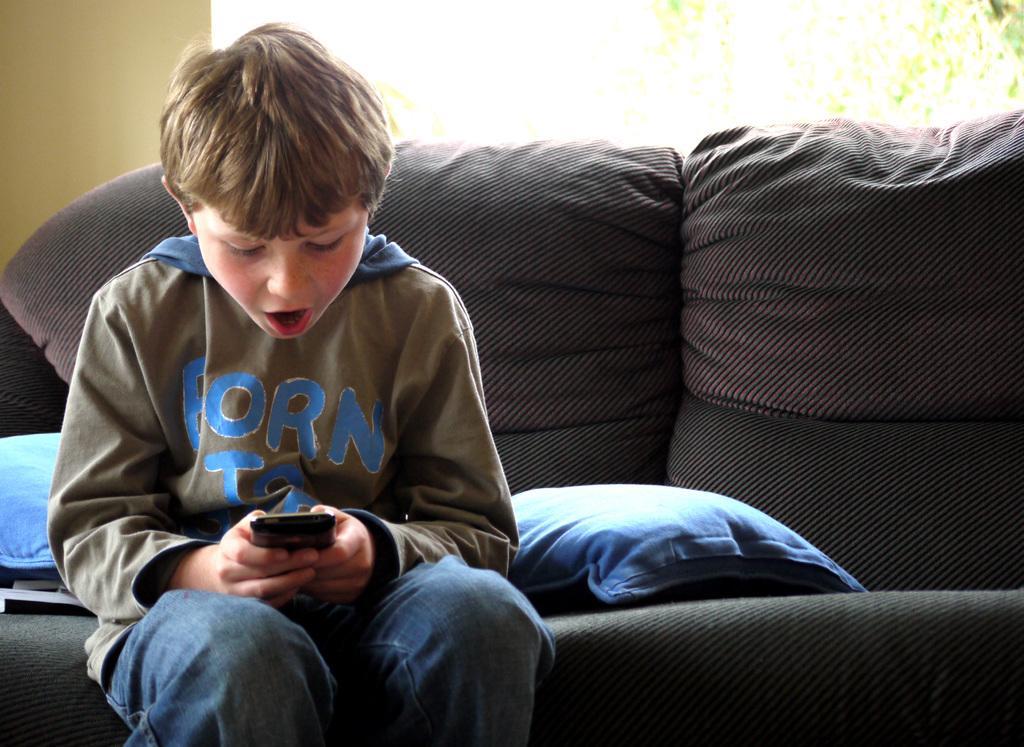Could you give a brief overview of what you see in this image? In this image, we can see a boy is sitting on the couch and holding black color device. Here we can see cushions and some objects. Top of the image, there is a wall. On the right top corner, we can see green color objects. 